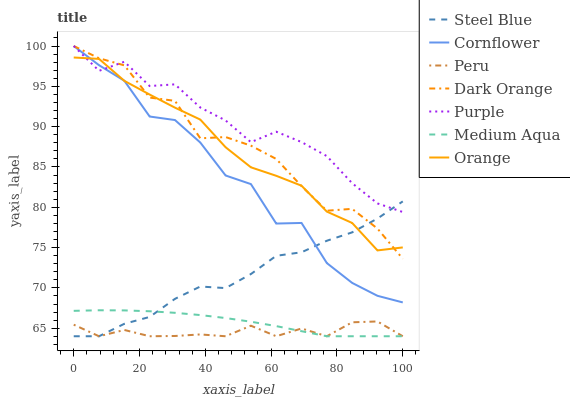Does Peru have the minimum area under the curve?
Answer yes or no. Yes. Does Purple have the maximum area under the curve?
Answer yes or no. Yes. Does Dark Orange have the minimum area under the curve?
Answer yes or no. No. Does Dark Orange have the maximum area under the curve?
Answer yes or no. No. Is Medium Aqua the smoothest?
Answer yes or no. Yes. Is Cornflower the roughest?
Answer yes or no. Yes. Is Dark Orange the smoothest?
Answer yes or no. No. Is Dark Orange the roughest?
Answer yes or no. No. Does Dark Orange have the lowest value?
Answer yes or no. No. Does Purple have the highest value?
Answer yes or no. Yes. Does Steel Blue have the highest value?
Answer yes or no. No. Is Peru less than Dark Orange?
Answer yes or no. Yes. Is Purple greater than Peru?
Answer yes or no. Yes. Does Orange intersect Cornflower?
Answer yes or no. Yes. Is Orange less than Cornflower?
Answer yes or no. No. Is Orange greater than Cornflower?
Answer yes or no. No. Does Peru intersect Dark Orange?
Answer yes or no. No. 